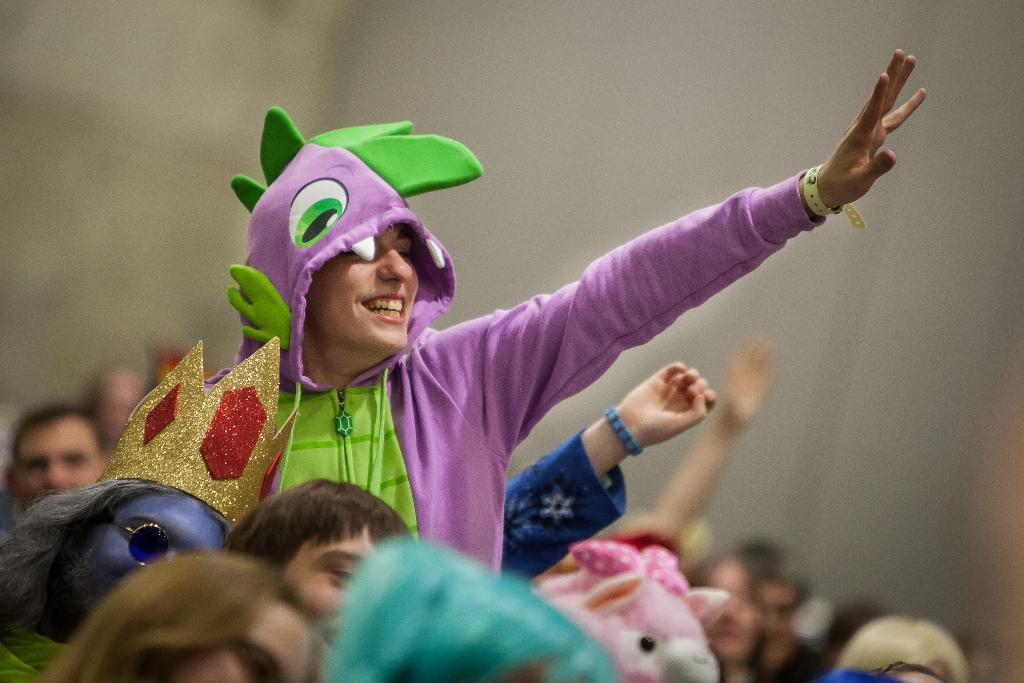Could you give a brief overview of what you see in this image? As we can see in the image in the front there are group of people and the background is blurred. The woman is wearing pink color dress. 